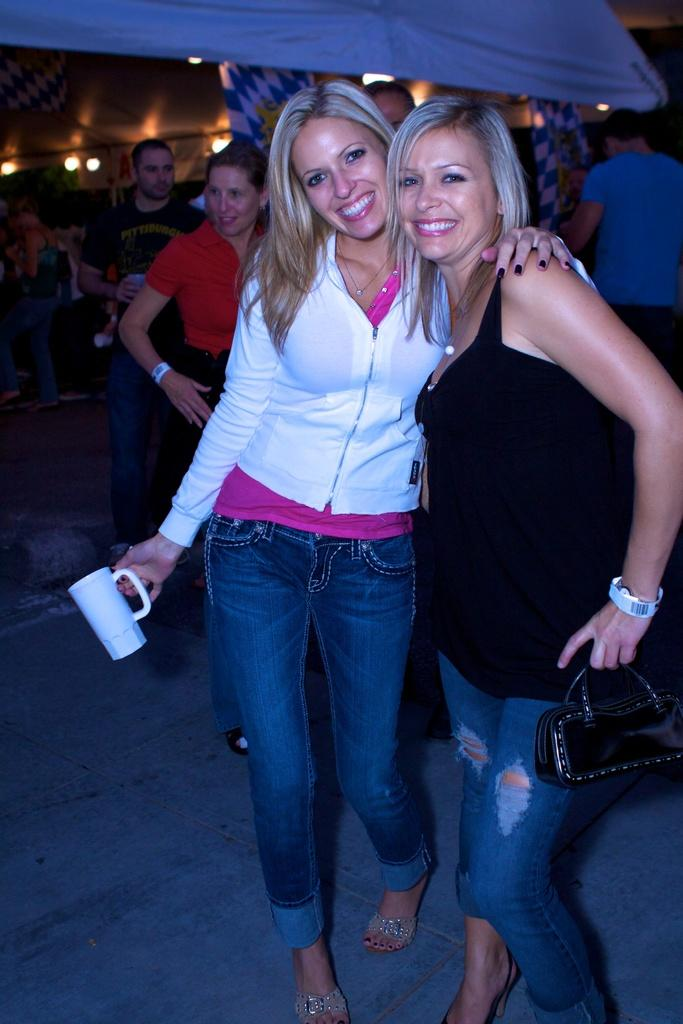How many individuals can be seen in the image? There are many people in the image. What is one lady holding in the image? One lady is holding a purse. What is another lady holding in the image? Another lady is holding a glass. What can be seen in the background of the image? There are lights visible in the background of the image. What type of fan is being used by the lady holding a pencil in the image? There is no lady holding a pencil in the image, and no fan is visible. 